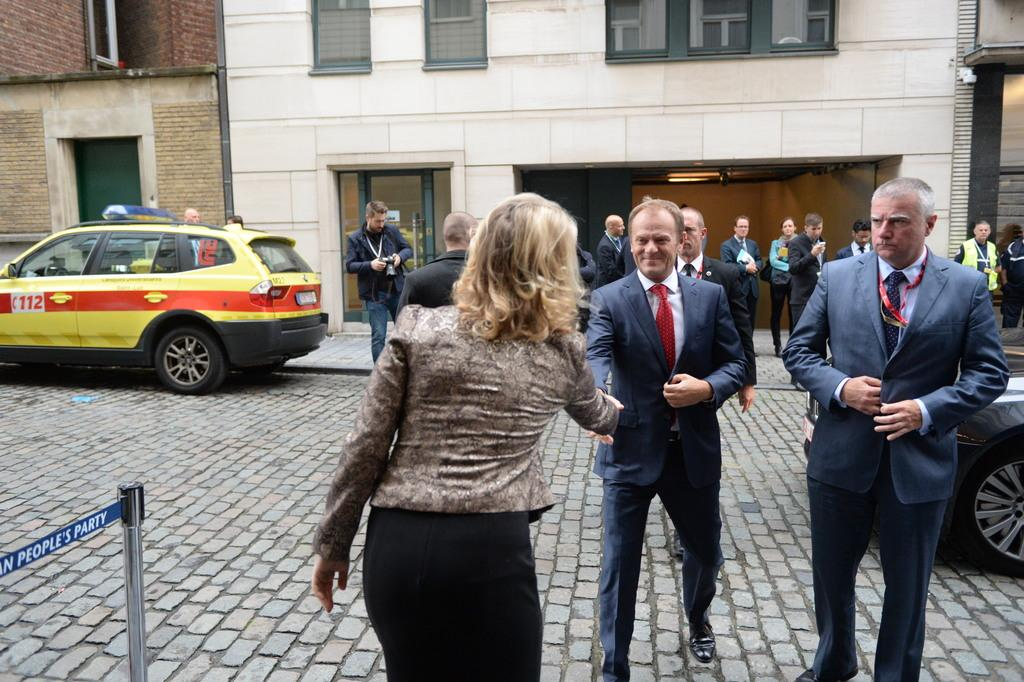What are the people in the image doing? The persons standing on the ground are likely waiting or observing something. How many vehicles can be seen in the image? There are two vehicles in the image. What is the tall, vertical object in the image? There is a pole in the image. What can be seen in the distance behind the people and vehicles? There is a building in the background. What feature of the building is mentioned in the facts? The building has windows visible on it. What type of news is being reported by the dolls in the image? There are no dolls present in the image, so there is no news being reported by them. 